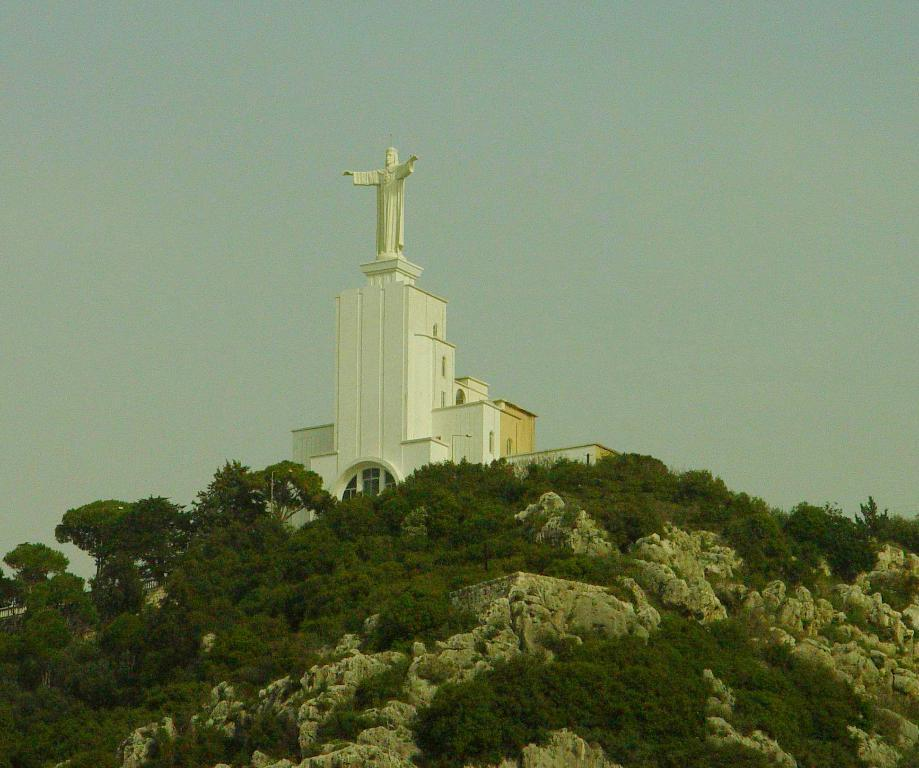What type of vegetation is at the bottom of the image? There are trees at the bottom of the image. What type of building is in the middle of the image? There is a church in the middle of the image. What is the color of the church? The church is white in color. What is on top of the church? There is a statue on the church. What is visible in the background of the image? The sky is visible in the image. What type of noise can be heard coming from the church in the image? There is no indication of any noise in the image, so it's not possible to determine what, if any, noise might be heard. What color is the sky in the image? The provided facts do not specify the color of the sky, only that it is visible. 